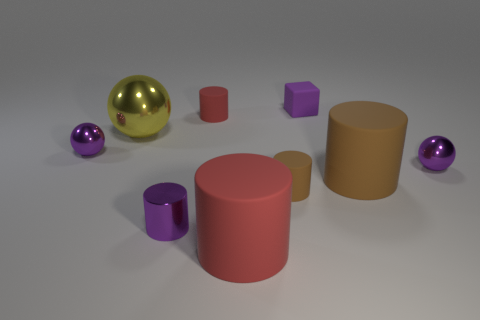The metal cylinder that is the same size as the block is what color?
Provide a succinct answer. Purple. What number of things are either metal balls that are to the right of the small red matte thing or objects that are on the left side of the block?
Ensure brevity in your answer.  7. Are there the same number of small purple cubes that are to the left of the tiny purple rubber object and big brown metallic objects?
Give a very brief answer. Yes. There is a purple object to the left of the tiny purple cylinder; is it the same size as the purple object behind the yellow object?
Ensure brevity in your answer.  Yes. What number of other objects are there of the same size as the matte block?
Provide a short and direct response. 5. There is a small purple rubber object that is behind the tiny purple sphere right of the large yellow object; is there a big cylinder that is behind it?
Give a very brief answer. No. Is there anything else of the same color as the small block?
Offer a terse response. Yes. What is the size of the rubber cylinder in front of the small purple shiny cylinder?
Your response must be concise. Large. What is the size of the brown matte thing that is in front of the large rubber thing that is behind the large rubber thing that is left of the large brown matte cylinder?
Your answer should be very brief. Small. The small cube right of the small purple shiny thing that is on the left side of the large shiny object is what color?
Your answer should be compact. Purple. 